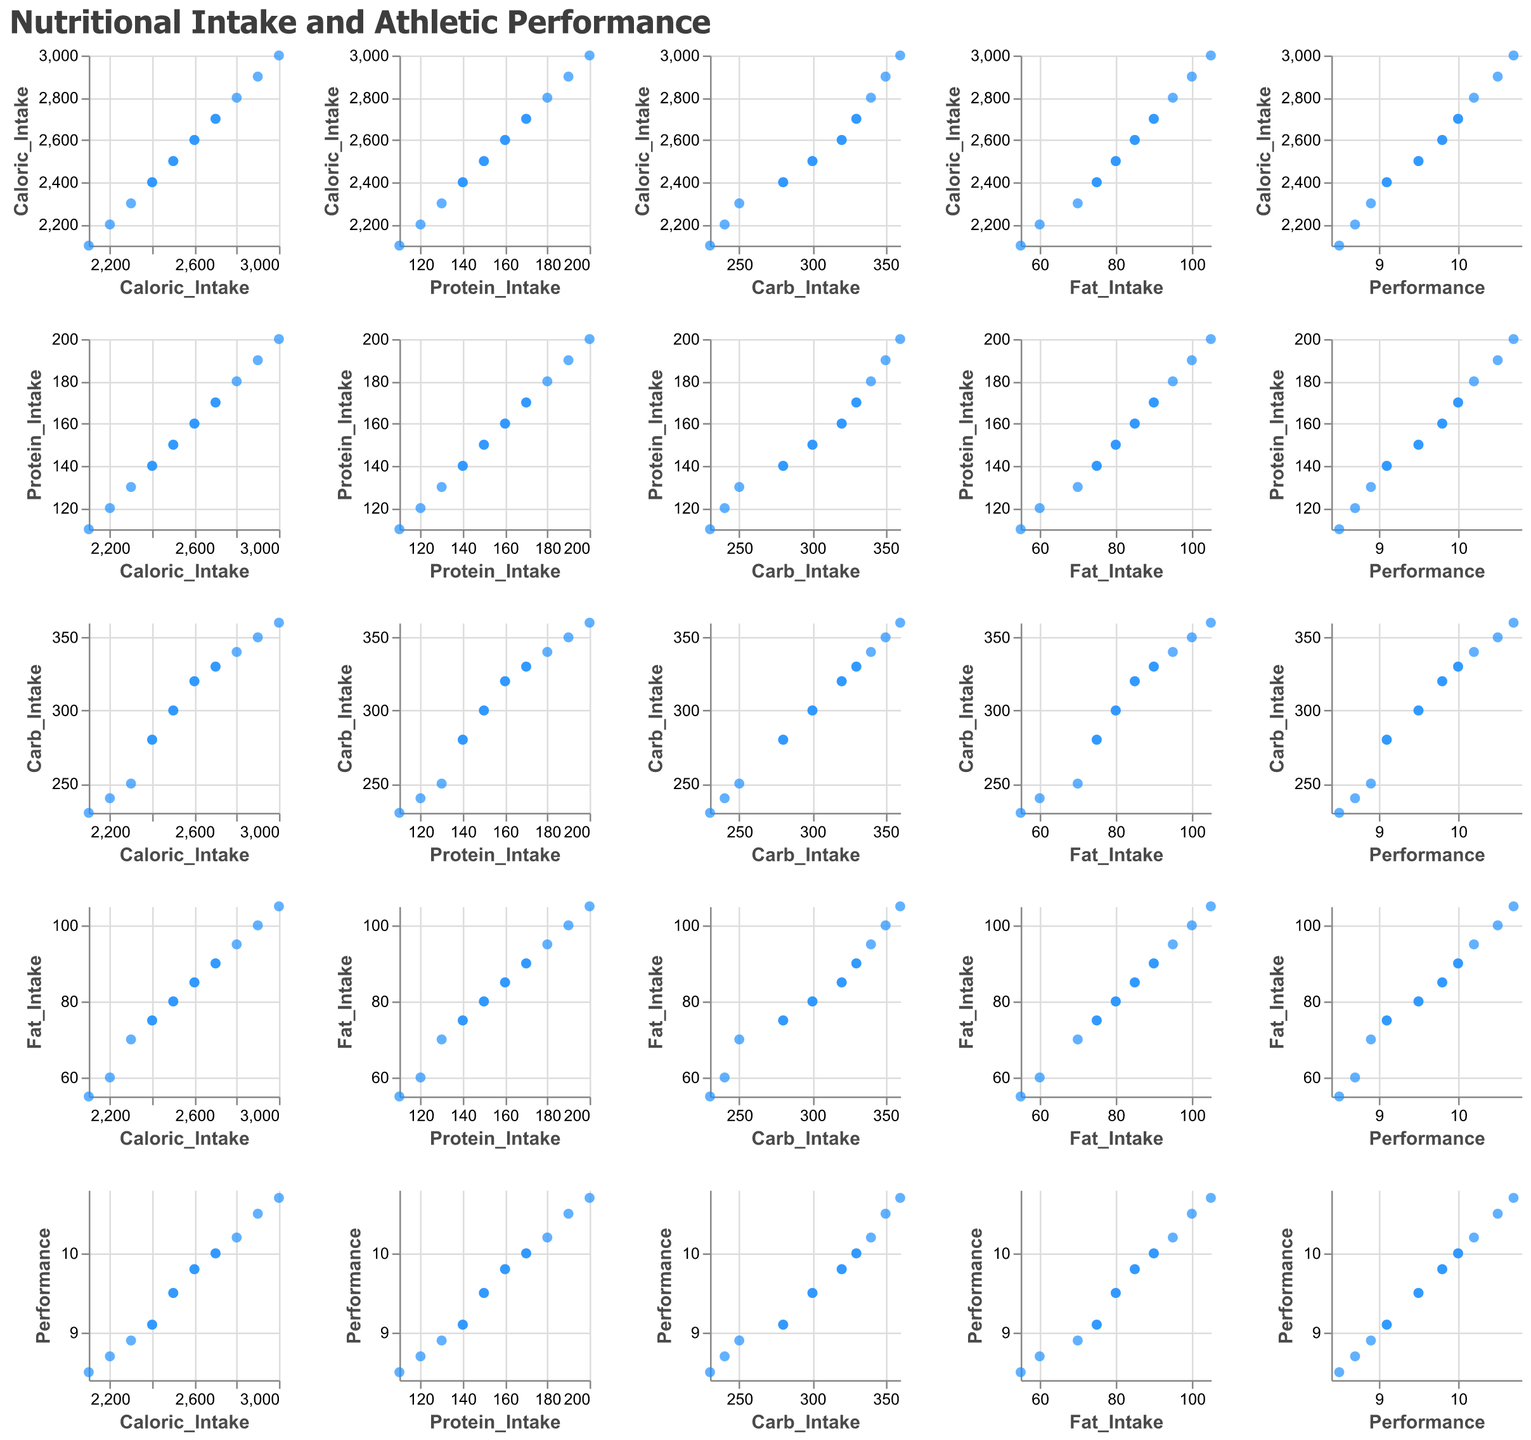What is the relationship between caloric intake and athletic performance? To determine the relationship, examine the scatter plot where the X-axis represents caloric intake and the Y-axis represents performance. Look for any trend, such as whether higher caloric intake correlates with better performance.
Answer: Generally, higher caloric intake is associated with better performance How many data points are plotted in the entire scatter plot matrix? Count the number of unique athletes provided in the data, which are represented by points in the scatter plot matrix.
Answer: 14 Is there a stronger correlation between protein intake and athletic performance or between carb intake and athletic performance? Compare the scatter plots of protein intake vs. performance and carb intake vs. performance. Assess which plot shows a clearer linear trend or closer clustering of points along a line.
Answer: Protein intake and performance have a stronger correlation Which athlete has the highest performance, and what is their caloric intake? Identify the highest value on the performance axis, locate the corresponding data point, and then check its caloric intake value.
Answer: Athlete 10 with a caloric intake of 3000 What is the average performance of athletes with a caloric intake above 2500? Identify the athletes with caloric intake above 2500, sum their performance scores, and divide by the number of such athletes. Athletes meeting the criteria are: Athlete 2, Athlete 4, Athlete 6, Athlete 8, Athlete 10, Athlete 12, Athlete 14. Their performances are (9.8, 10.0, 10.2, 10.5, 10.7, 9.8, 10.0). Calculate the average: (9.8+10.0+10.2+10.5+10.7+9.8+10.0)/7 = 10.14.
Answer: 10.14 Do any two athletes have identical nutritional intake and performance values? Examine the scatter plot matrix to see if any two data points overlap completely in all plots, indicating identical values across all variables.
Answer: Athlete 1 and Athlete 11 have identical values Is fat intake more closely related to caloric intake or performance? Compare the scatter plots of fat intake vs. caloric intake and fat intake vs. performance. Determine which plot shows a more defined trend or stronger clustering of points.
Answer: Fat intake is more closely related to caloric intake What is the trend between carbohydrate intake and performance? Look at the scatter plot where carbohydrate intake is on the X-axis and performance on the Y-axis. Determine if the trend is positive, negative, or neutral.
Answer: Positive trend Which nutritional intake metric shows the least variation among athletes? Examine the respective scatter plots and identify the metric whose points are least spread out across their respective axis.
Answer: Fat intake 